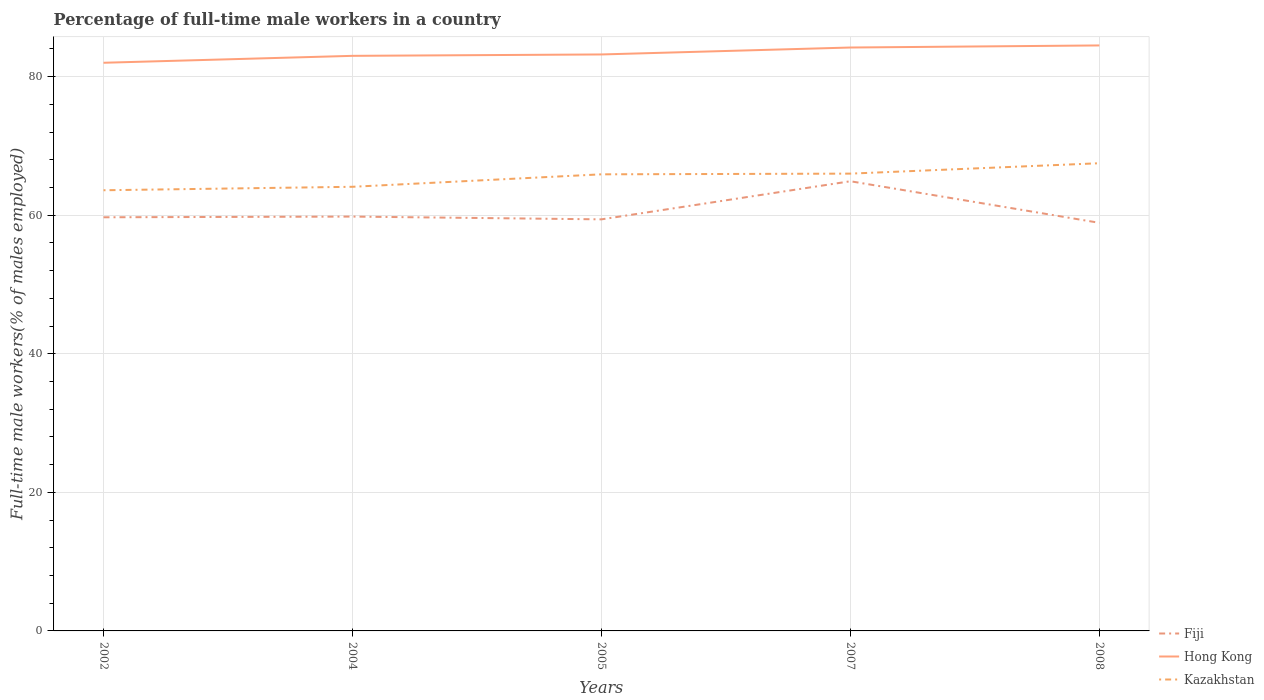Does the line corresponding to Fiji intersect with the line corresponding to Kazakhstan?
Ensure brevity in your answer.  No. Across all years, what is the maximum percentage of full-time male workers in Fiji?
Keep it short and to the point. 58.9. In which year was the percentage of full-time male workers in Kazakhstan maximum?
Ensure brevity in your answer.  2002. What is the total percentage of full-time male workers in Fiji in the graph?
Give a very brief answer. -5.1. What is the difference between the highest and the second highest percentage of full-time male workers in Hong Kong?
Offer a very short reply. 2.5. Is the percentage of full-time male workers in Hong Kong strictly greater than the percentage of full-time male workers in Kazakhstan over the years?
Your answer should be very brief. No. How many lines are there?
Provide a succinct answer. 3. What is the difference between two consecutive major ticks on the Y-axis?
Your response must be concise. 20. Does the graph contain any zero values?
Offer a terse response. No. How are the legend labels stacked?
Give a very brief answer. Vertical. What is the title of the graph?
Your answer should be compact. Percentage of full-time male workers in a country. What is the label or title of the Y-axis?
Make the answer very short. Full-time male workers(% of males employed). What is the Full-time male workers(% of males employed) in Fiji in 2002?
Keep it short and to the point. 59.7. What is the Full-time male workers(% of males employed) of Kazakhstan in 2002?
Offer a very short reply. 63.6. What is the Full-time male workers(% of males employed) in Fiji in 2004?
Provide a succinct answer. 59.8. What is the Full-time male workers(% of males employed) in Kazakhstan in 2004?
Give a very brief answer. 64.1. What is the Full-time male workers(% of males employed) of Fiji in 2005?
Your answer should be compact. 59.4. What is the Full-time male workers(% of males employed) in Hong Kong in 2005?
Offer a very short reply. 83.2. What is the Full-time male workers(% of males employed) in Kazakhstan in 2005?
Offer a very short reply. 65.9. What is the Full-time male workers(% of males employed) of Fiji in 2007?
Give a very brief answer. 64.9. What is the Full-time male workers(% of males employed) in Hong Kong in 2007?
Your answer should be very brief. 84.2. What is the Full-time male workers(% of males employed) in Kazakhstan in 2007?
Provide a succinct answer. 66. What is the Full-time male workers(% of males employed) of Fiji in 2008?
Offer a terse response. 58.9. What is the Full-time male workers(% of males employed) in Hong Kong in 2008?
Your answer should be compact. 84.5. What is the Full-time male workers(% of males employed) in Kazakhstan in 2008?
Offer a very short reply. 67.5. Across all years, what is the maximum Full-time male workers(% of males employed) of Fiji?
Make the answer very short. 64.9. Across all years, what is the maximum Full-time male workers(% of males employed) of Hong Kong?
Ensure brevity in your answer.  84.5. Across all years, what is the maximum Full-time male workers(% of males employed) of Kazakhstan?
Give a very brief answer. 67.5. Across all years, what is the minimum Full-time male workers(% of males employed) in Fiji?
Your response must be concise. 58.9. Across all years, what is the minimum Full-time male workers(% of males employed) in Kazakhstan?
Offer a terse response. 63.6. What is the total Full-time male workers(% of males employed) in Fiji in the graph?
Your answer should be very brief. 302.7. What is the total Full-time male workers(% of males employed) of Hong Kong in the graph?
Provide a succinct answer. 416.9. What is the total Full-time male workers(% of males employed) in Kazakhstan in the graph?
Provide a succinct answer. 327.1. What is the difference between the Full-time male workers(% of males employed) in Fiji in 2002 and that in 2005?
Your answer should be very brief. 0.3. What is the difference between the Full-time male workers(% of males employed) in Hong Kong in 2002 and that in 2005?
Your answer should be very brief. -1.2. What is the difference between the Full-time male workers(% of males employed) of Kazakhstan in 2002 and that in 2005?
Give a very brief answer. -2.3. What is the difference between the Full-time male workers(% of males employed) in Fiji in 2002 and that in 2007?
Give a very brief answer. -5.2. What is the difference between the Full-time male workers(% of males employed) of Hong Kong in 2002 and that in 2007?
Make the answer very short. -2.2. What is the difference between the Full-time male workers(% of males employed) in Fiji in 2002 and that in 2008?
Your answer should be very brief. 0.8. What is the difference between the Full-time male workers(% of males employed) in Fiji in 2004 and that in 2005?
Give a very brief answer. 0.4. What is the difference between the Full-time male workers(% of males employed) of Hong Kong in 2004 and that in 2005?
Offer a very short reply. -0.2. What is the difference between the Full-time male workers(% of males employed) of Kazakhstan in 2004 and that in 2005?
Ensure brevity in your answer.  -1.8. What is the difference between the Full-time male workers(% of males employed) in Fiji in 2004 and that in 2007?
Your answer should be compact. -5.1. What is the difference between the Full-time male workers(% of males employed) of Hong Kong in 2004 and that in 2007?
Provide a succinct answer. -1.2. What is the difference between the Full-time male workers(% of males employed) in Kazakhstan in 2004 and that in 2007?
Keep it short and to the point. -1.9. What is the difference between the Full-time male workers(% of males employed) of Fiji in 2004 and that in 2008?
Provide a short and direct response. 0.9. What is the difference between the Full-time male workers(% of males employed) in Hong Kong in 2004 and that in 2008?
Offer a terse response. -1.5. What is the difference between the Full-time male workers(% of males employed) of Kazakhstan in 2004 and that in 2008?
Ensure brevity in your answer.  -3.4. What is the difference between the Full-time male workers(% of males employed) of Fiji in 2005 and that in 2007?
Provide a succinct answer. -5.5. What is the difference between the Full-time male workers(% of males employed) of Kazakhstan in 2005 and that in 2007?
Offer a terse response. -0.1. What is the difference between the Full-time male workers(% of males employed) of Hong Kong in 2005 and that in 2008?
Make the answer very short. -1.3. What is the difference between the Full-time male workers(% of males employed) of Fiji in 2002 and the Full-time male workers(% of males employed) of Hong Kong in 2004?
Your answer should be compact. -23.3. What is the difference between the Full-time male workers(% of males employed) in Hong Kong in 2002 and the Full-time male workers(% of males employed) in Kazakhstan in 2004?
Your answer should be very brief. 17.9. What is the difference between the Full-time male workers(% of males employed) of Fiji in 2002 and the Full-time male workers(% of males employed) of Hong Kong in 2005?
Your answer should be compact. -23.5. What is the difference between the Full-time male workers(% of males employed) in Fiji in 2002 and the Full-time male workers(% of males employed) in Hong Kong in 2007?
Provide a short and direct response. -24.5. What is the difference between the Full-time male workers(% of males employed) in Fiji in 2002 and the Full-time male workers(% of males employed) in Hong Kong in 2008?
Ensure brevity in your answer.  -24.8. What is the difference between the Full-time male workers(% of males employed) of Hong Kong in 2002 and the Full-time male workers(% of males employed) of Kazakhstan in 2008?
Make the answer very short. 14.5. What is the difference between the Full-time male workers(% of males employed) of Fiji in 2004 and the Full-time male workers(% of males employed) of Hong Kong in 2005?
Make the answer very short. -23.4. What is the difference between the Full-time male workers(% of males employed) in Hong Kong in 2004 and the Full-time male workers(% of males employed) in Kazakhstan in 2005?
Offer a very short reply. 17.1. What is the difference between the Full-time male workers(% of males employed) of Fiji in 2004 and the Full-time male workers(% of males employed) of Hong Kong in 2007?
Your response must be concise. -24.4. What is the difference between the Full-time male workers(% of males employed) of Fiji in 2004 and the Full-time male workers(% of males employed) of Hong Kong in 2008?
Offer a terse response. -24.7. What is the difference between the Full-time male workers(% of males employed) of Fiji in 2004 and the Full-time male workers(% of males employed) of Kazakhstan in 2008?
Provide a short and direct response. -7.7. What is the difference between the Full-time male workers(% of males employed) in Fiji in 2005 and the Full-time male workers(% of males employed) in Hong Kong in 2007?
Offer a terse response. -24.8. What is the difference between the Full-time male workers(% of males employed) of Hong Kong in 2005 and the Full-time male workers(% of males employed) of Kazakhstan in 2007?
Make the answer very short. 17.2. What is the difference between the Full-time male workers(% of males employed) in Fiji in 2005 and the Full-time male workers(% of males employed) in Hong Kong in 2008?
Your answer should be compact. -25.1. What is the difference between the Full-time male workers(% of males employed) of Fiji in 2005 and the Full-time male workers(% of males employed) of Kazakhstan in 2008?
Provide a short and direct response. -8.1. What is the difference between the Full-time male workers(% of males employed) of Fiji in 2007 and the Full-time male workers(% of males employed) of Hong Kong in 2008?
Keep it short and to the point. -19.6. What is the difference between the Full-time male workers(% of males employed) of Fiji in 2007 and the Full-time male workers(% of males employed) of Kazakhstan in 2008?
Provide a succinct answer. -2.6. What is the average Full-time male workers(% of males employed) of Fiji per year?
Ensure brevity in your answer.  60.54. What is the average Full-time male workers(% of males employed) of Hong Kong per year?
Provide a succinct answer. 83.38. What is the average Full-time male workers(% of males employed) of Kazakhstan per year?
Offer a terse response. 65.42. In the year 2002, what is the difference between the Full-time male workers(% of males employed) in Fiji and Full-time male workers(% of males employed) in Hong Kong?
Give a very brief answer. -22.3. In the year 2004, what is the difference between the Full-time male workers(% of males employed) in Fiji and Full-time male workers(% of males employed) in Hong Kong?
Offer a very short reply. -23.2. In the year 2004, what is the difference between the Full-time male workers(% of males employed) of Fiji and Full-time male workers(% of males employed) of Kazakhstan?
Offer a terse response. -4.3. In the year 2005, what is the difference between the Full-time male workers(% of males employed) in Fiji and Full-time male workers(% of males employed) in Hong Kong?
Your answer should be very brief. -23.8. In the year 2005, what is the difference between the Full-time male workers(% of males employed) of Fiji and Full-time male workers(% of males employed) of Kazakhstan?
Provide a succinct answer. -6.5. In the year 2007, what is the difference between the Full-time male workers(% of males employed) of Fiji and Full-time male workers(% of males employed) of Hong Kong?
Provide a succinct answer. -19.3. In the year 2007, what is the difference between the Full-time male workers(% of males employed) in Fiji and Full-time male workers(% of males employed) in Kazakhstan?
Your answer should be very brief. -1.1. In the year 2007, what is the difference between the Full-time male workers(% of males employed) of Hong Kong and Full-time male workers(% of males employed) of Kazakhstan?
Your response must be concise. 18.2. In the year 2008, what is the difference between the Full-time male workers(% of males employed) in Fiji and Full-time male workers(% of males employed) in Hong Kong?
Provide a short and direct response. -25.6. What is the ratio of the Full-time male workers(% of males employed) in Kazakhstan in 2002 to that in 2004?
Provide a short and direct response. 0.99. What is the ratio of the Full-time male workers(% of males employed) in Hong Kong in 2002 to that in 2005?
Your answer should be very brief. 0.99. What is the ratio of the Full-time male workers(% of males employed) of Kazakhstan in 2002 to that in 2005?
Offer a very short reply. 0.97. What is the ratio of the Full-time male workers(% of males employed) of Fiji in 2002 to that in 2007?
Give a very brief answer. 0.92. What is the ratio of the Full-time male workers(% of males employed) in Hong Kong in 2002 to that in 2007?
Your answer should be compact. 0.97. What is the ratio of the Full-time male workers(% of males employed) of Kazakhstan in 2002 to that in 2007?
Your response must be concise. 0.96. What is the ratio of the Full-time male workers(% of males employed) in Fiji in 2002 to that in 2008?
Ensure brevity in your answer.  1.01. What is the ratio of the Full-time male workers(% of males employed) in Hong Kong in 2002 to that in 2008?
Your answer should be very brief. 0.97. What is the ratio of the Full-time male workers(% of males employed) in Kazakhstan in 2002 to that in 2008?
Provide a short and direct response. 0.94. What is the ratio of the Full-time male workers(% of males employed) of Fiji in 2004 to that in 2005?
Your response must be concise. 1.01. What is the ratio of the Full-time male workers(% of males employed) of Kazakhstan in 2004 to that in 2005?
Your answer should be compact. 0.97. What is the ratio of the Full-time male workers(% of males employed) in Fiji in 2004 to that in 2007?
Make the answer very short. 0.92. What is the ratio of the Full-time male workers(% of males employed) in Hong Kong in 2004 to that in 2007?
Your answer should be very brief. 0.99. What is the ratio of the Full-time male workers(% of males employed) of Kazakhstan in 2004 to that in 2007?
Ensure brevity in your answer.  0.97. What is the ratio of the Full-time male workers(% of males employed) in Fiji in 2004 to that in 2008?
Keep it short and to the point. 1.02. What is the ratio of the Full-time male workers(% of males employed) in Hong Kong in 2004 to that in 2008?
Offer a very short reply. 0.98. What is the ratio of the Full-time male workers(% of males employed) of Kazakhstan in 2004 to that in 2008?
Keep it short and to the point. 0.95. What is the ratio of the Full-time male workers(% of males employed) of Fiji in 2005 to that in 2007?
Provide a short and direct response. 0.92. What is the ratio of the Full-time male workers(% of males employed) in Fiji in 2005 to that in 2008?
Provide a short and direct response. 1.01. What is the ratio of the Full-time male workers(% of males employed) in Hong Kong in 2005 to that in 2008?
Offer a terse response. 0.98. What is the ratio of the Full-time male workers(% of males employed) in Kazakhstan in 2005 to that in 2008?
Offer a very short reply. 0.98. What is the ratio of the Full-time male workers(% of males employed) of Fiji in 2007 to that in 2008?
Provide a succinct answer. 1.1. What is the ratio of the Full-time male workers(% of males employed) of Hong Kong in 2007 to that in 2008?
Provide a short and direct response. 1. What is the ratio of the Full-time male workers(% of males employed) of Kazakhstan in 2007 to that in 2008?
Offer a very short reply. 0.98. What is the difference between the highest and the second highest Full-time male workers(% of males employed) in Fiji?
Offer a very short reply. 5.1. What is the difference between the highest and the second highest Full-time male workers(% of males employed) of Hong Kong?
Your answer should be compact. 0.3. What is the difference between the highest and the second highest Full-time male workers(% of males employed) of Kazakhstan?
Ensure brevity in your answer.  1.5. What is the difference between the highest and the lowest Full-time male workers(% of males employed) in Kazakhstan?
Keep it short and to the point. 3.9. 